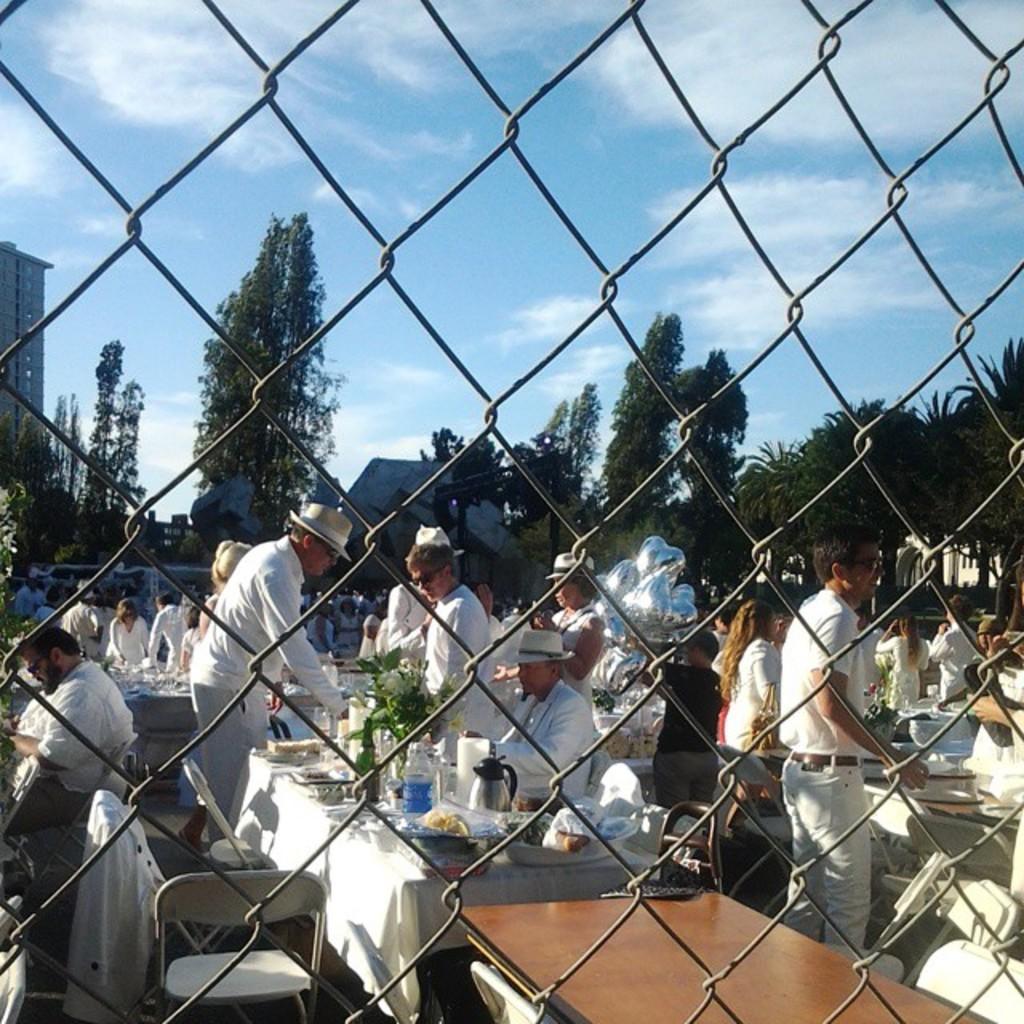Could you give a brief overview of what you see in this image? In this image, we can see a mesh, a group of people. Few are sitting and standing. Here we can see chairs and tables. Few items are placed on it. Background there are so many trees, house, building and sky we can see. 